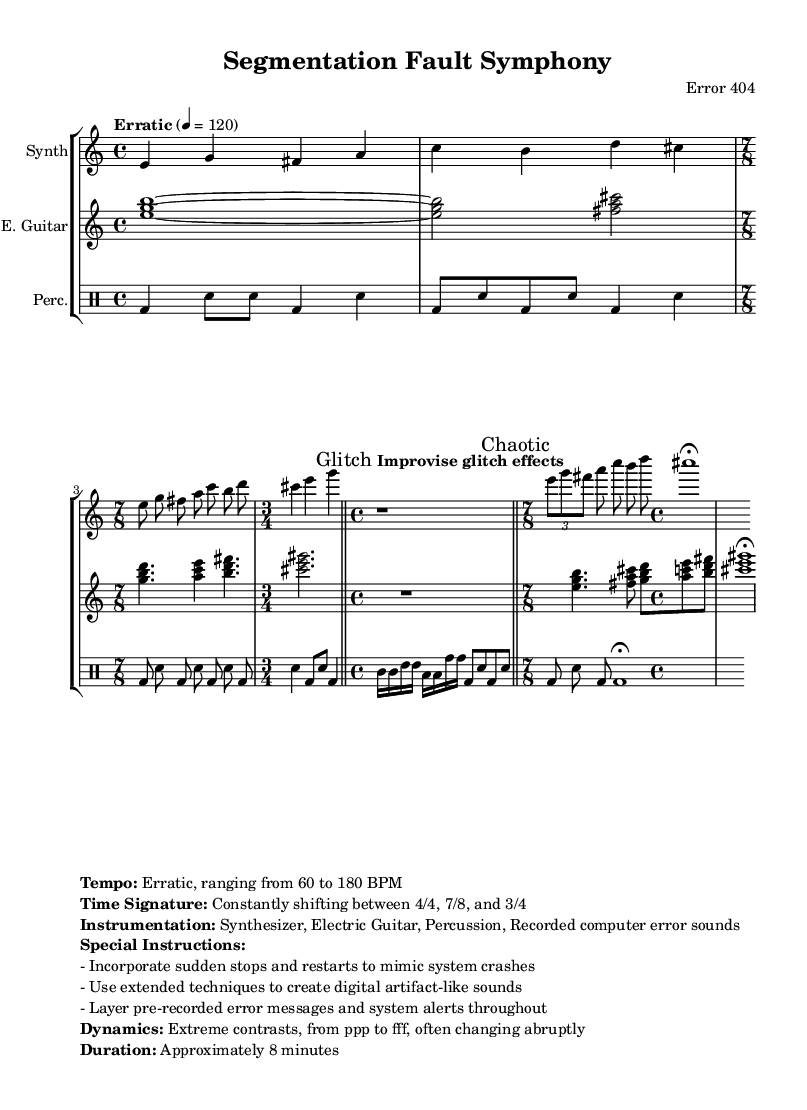What is the tempo marking of this music? The tempo marking is indicated as "Erratic" with a metronome marking of 120 for quarter notes.
Answer: Erratic 4 = 120 What is the signature time signature at the beginning of this piece? The score starts with a time signature of 4/4, as seen in the first measure.
Answer: 4/4 What is the spell of the first three measures for the synthesizer part? The pitches outlined in the first three measures are e, g, fis, a, c, b, d, and cis.
Answer: e, g, fis, a, c, b, d, cis What dynamic range is specified for this piece? The dynamics specified range from ppp to fff, meaning very soft to very loud, with abrupt changes.
Answer: ppp to fff What unique sound elements are incorporated in this composition? The composition incorporates recorded computer error sounds and pre-recorded error messages throughout the piece.
Answer: Recorded computer error sounds How does the piece suggest to handle improvisation? The score instructs the performer to "Improvise glitch effects" during specific measures to create unique sounds.
Answer: Improvise glitch effects What is the overall duration of this symphony? The overall duration of the piece is specified as approximately 8 minutes long.
Answer: Approximately 8 minutes 